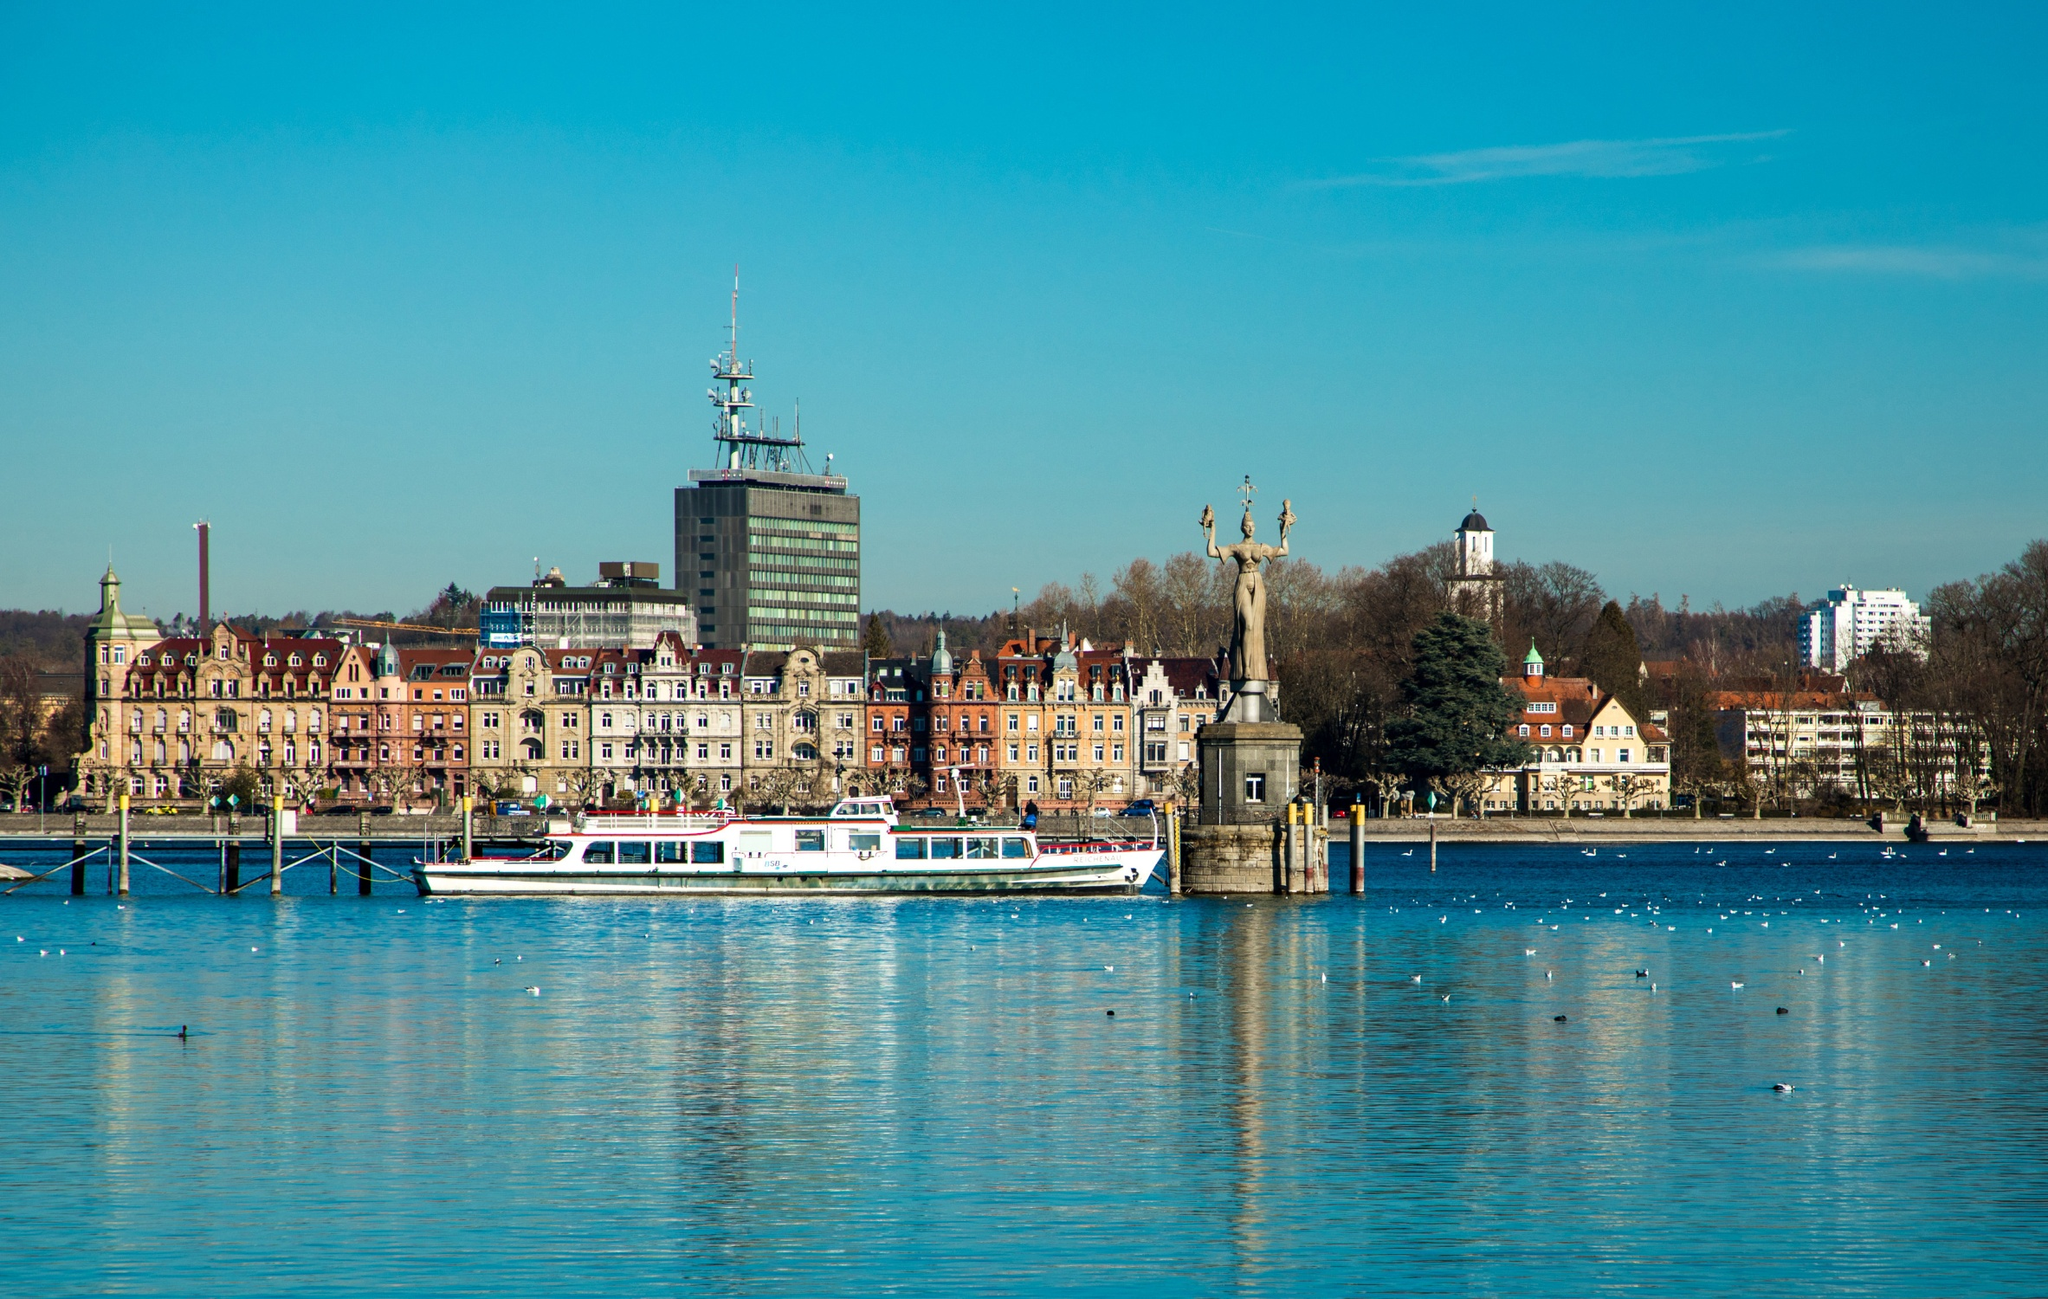What can you tell me about the history and significance of the statue on the right? The statue depicted is the Imperia statue, an iconic landmark at the entrance of Constance Harbour. Created by German sculptor Peter Lenk in 1993, it stands 9 meters tall and symbolizes a satirical take on the Catholic clergy's moral decline during the Council of Constance (1414–1418). The statue portrays a voluptuous woman holding figures of Pope Martin V and Emperor Sigismund, both rendered small and powerless, atop her hands. Imperia represents power and the seductive allure of authority, serving as a stark commentary on historical events and human folly.  If the statue could speak, what stories might it tell about Constance Harbour? The Imperia statue, if it could speak, would recount centuries of historical events, from the grandeur and corruption of the medieval papacy to the bustling trade and cultural exchanges that have taken place in Constance Harbour. It would share stories of the medieval council that sought to end the Papal Schism, regaling us with tales of intrigue, politics, and reformative decisions that shaped the course of history. The statue might also speak of the evolution of the harbour itself, narrating how it transformed from a modest medieval port into the picturesque and vibrant waterfront it is today, frequented by locals and tourists who admire its historical charm and modern vibrancy alike. 